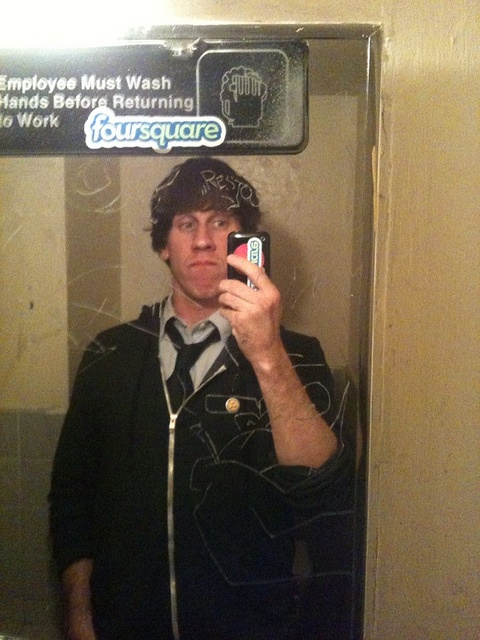Describe the objects in this image and their specific colors. I can see people in white, black, brown, and maroon tones, tie in white, black, and gray tones, and cell phone in white, black, maroon, ivory, and gray tones in this image. 